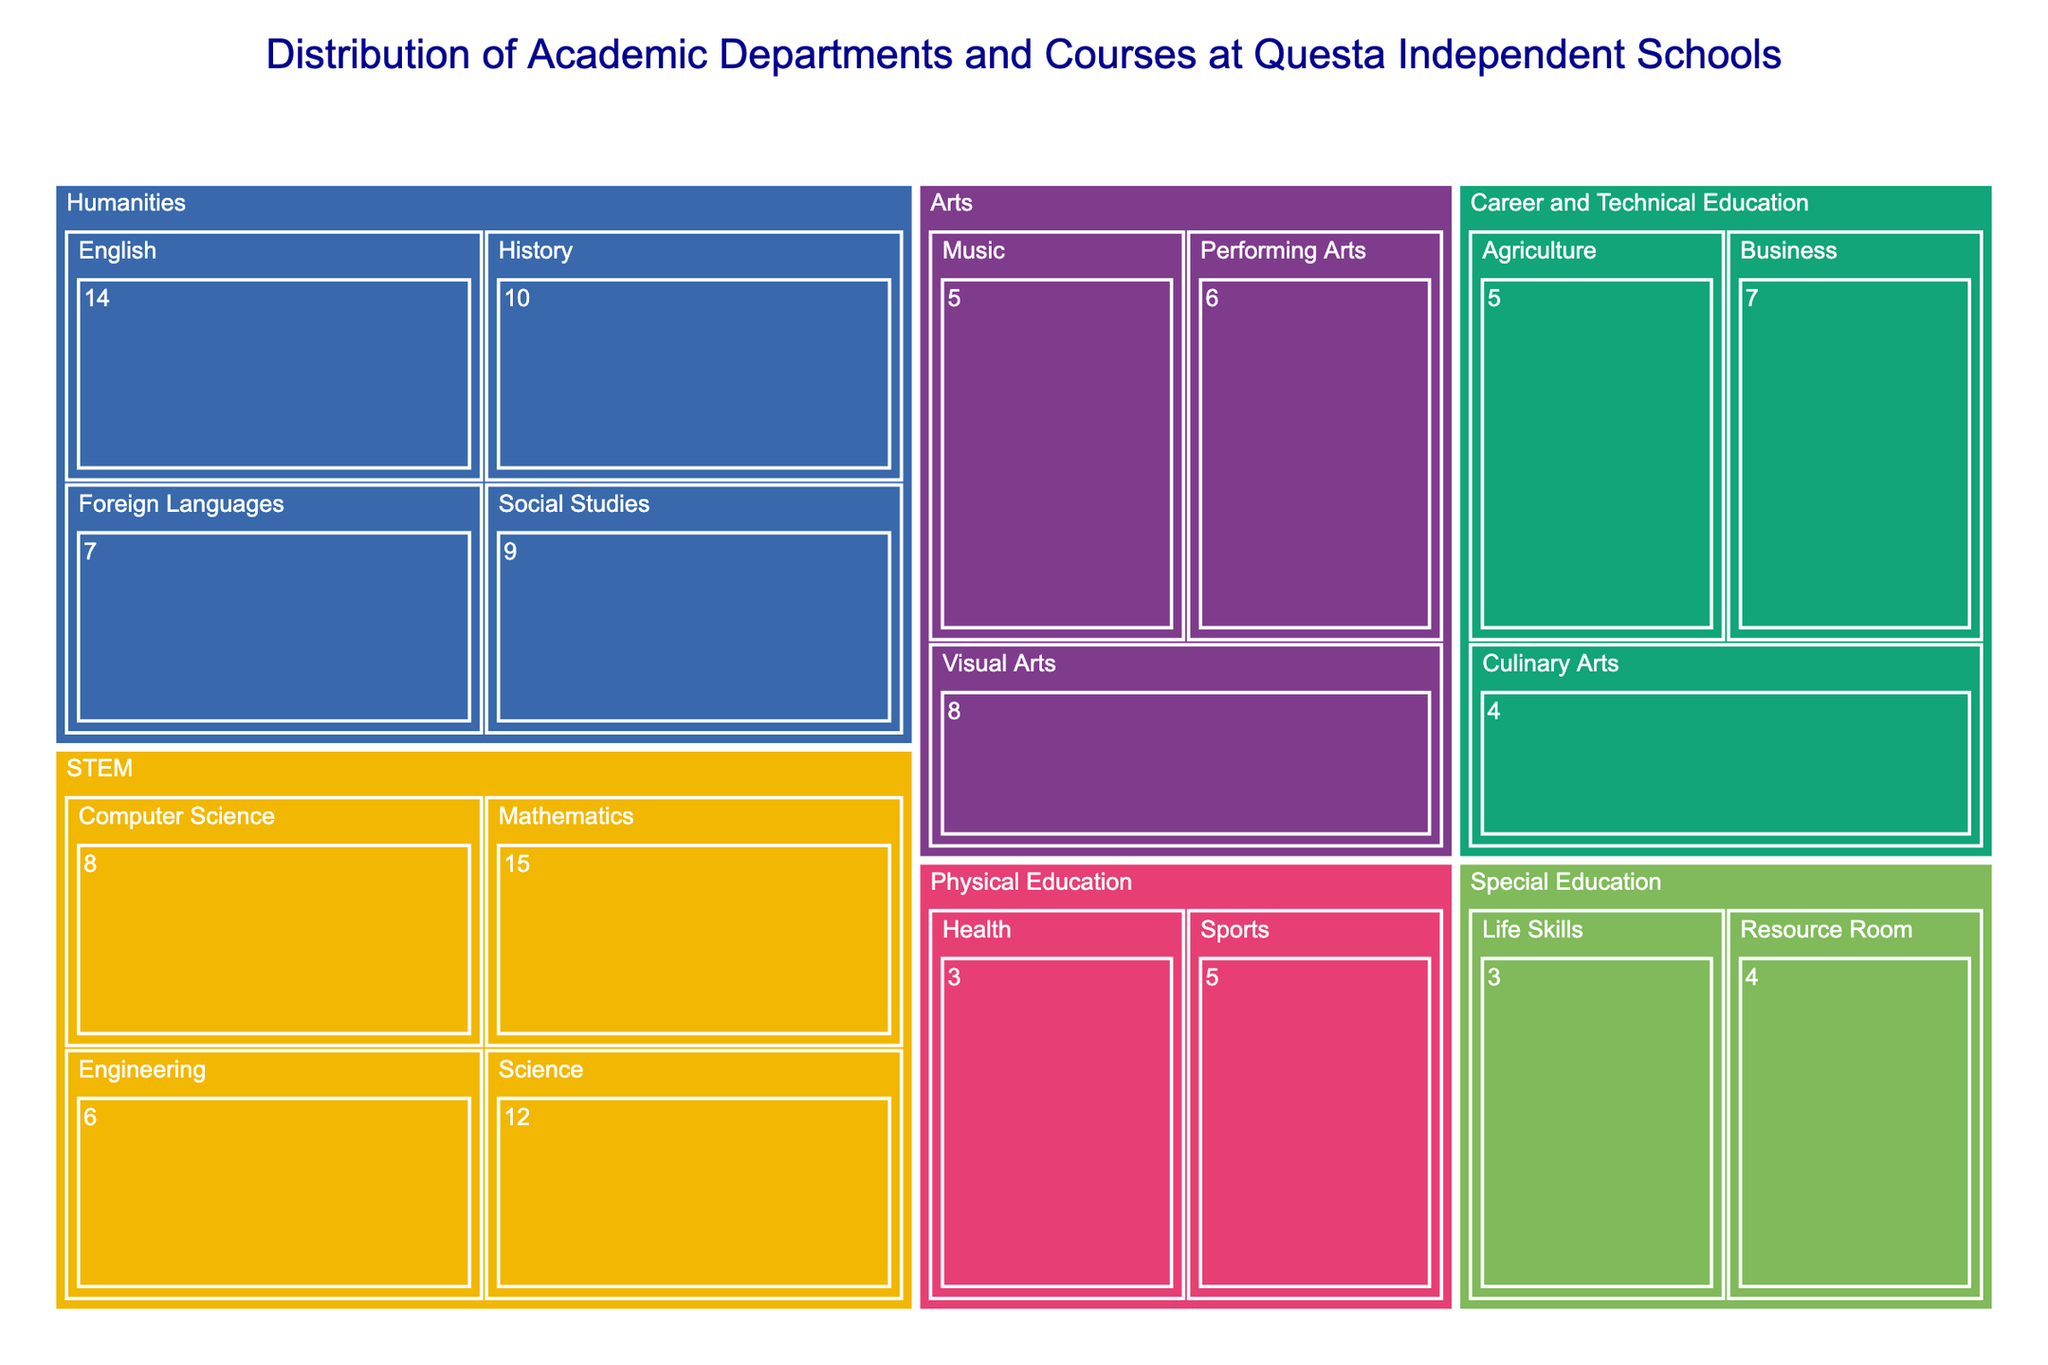What is the title of the treemap figure? The title of the figure is displayed at the top, providing a concise summary of the content it presents.
Answer: Distribution of Academic Departments and Courses at Questa Independent Schools How many courses does the Mathematics subject have? Locate the "Mathematics" subject block within the "STEM" department. The hover data or the displayed text will show the number of courses.
Answer: 15 Which department offers the most subjects? Count the unique subjects listed under each department on the treemap. The department with the highest count has the most subjects.
Answer: STEM Compare the number of courses offered in Mathematics and Science subjects. Which one has more? Refer to the blocks for "Mathematics" and "Science" in the "STEM" department. Compare the numbers associated with each.
Answer: Mathematics What is the total number of courses offered by the STEM department? Sum the courses of all subjects under the "STEM" department: Mathematics (15) + Science (12) + Computer Science (8) + Engineering (6).
Answer: 41 Which department offers the fewest courses? Identify the department with the smallest cumulative total by summing the courses of all subjects within each department and comparing them.
Answer: Physical Education How many courses are offered in total by the Arts department? Sum the courses in the "Visual Arts", "Performing Arts", and "Music" subjects under the "Arts" department: Visual Arts (8) + Performing Arts (6) + Music (5).
Answer: 19 Between the subjects "Foreign Languages" and "Agriculture", which one offers more courses? Locate the blocks for "Foreign Languages" under "Humanities" and "Agriculture" under "Career and Technical Education", then compare their course numbers.
Answer: Foreign Languages How does the number of English courses compare to the number of History courses? Find the "English" and "History" blocks within the "Humanities" department and compare the course counts: English (14) vs History (10).
Answer: English offers more What is the total number of courses offered across all departments? Sum all the courses from every subject listed in the treemap.
Answer: 123 